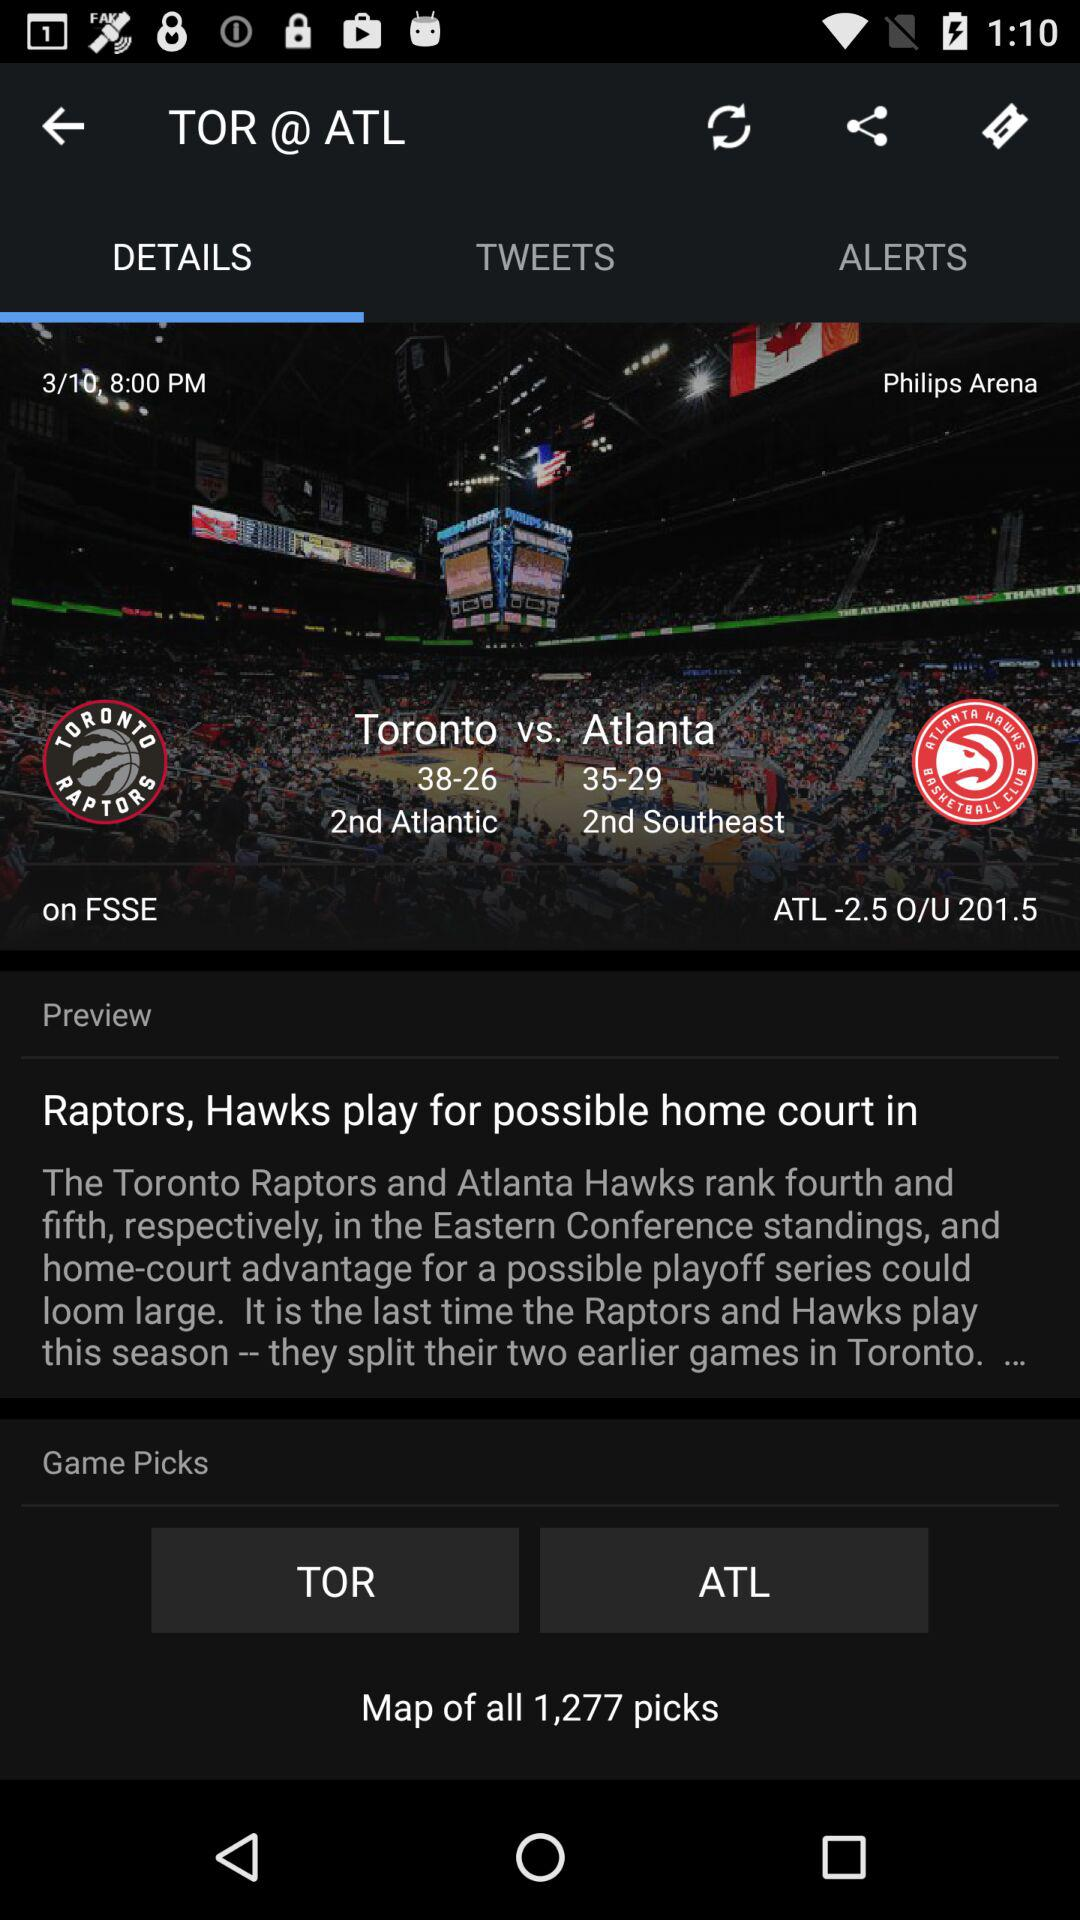What is the location of the match? The location is Philips Arena. 